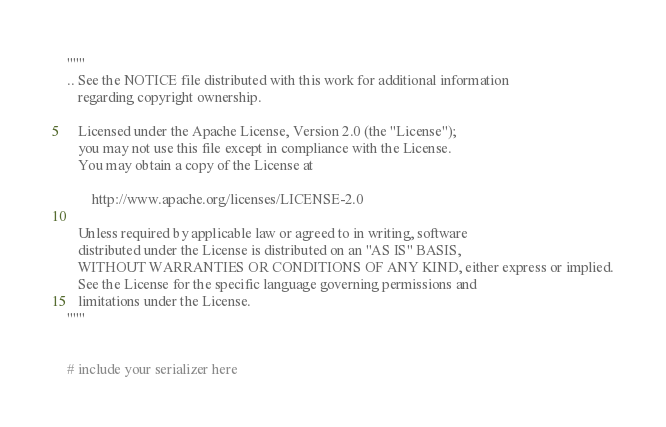<code> <loc_0><loc_0><loc_500><loc_500><_Python_>"""
.. See the NOTICE file distributed with this work for additional information
   regarding copyright ownership.

   Licensed under the Apache License, Version 2.0 (the "License");
   you may not use this file except in compliance with the License.
   You may obtain a copy of the License at

       http://www.apache.org/licenses/LICENSE-2.0

   Unless required by applicable law or agreed to in writing, software
   distributed under the License is distributed on an "AS IS" BASIS,
   WITHOUT WARRANTIES OR CONDITIONS OF ANY KIND, either express or implied.
   See the License for the specific language governing permissions and
   limitations under the License.
"""


# include your serializer here
</code> 